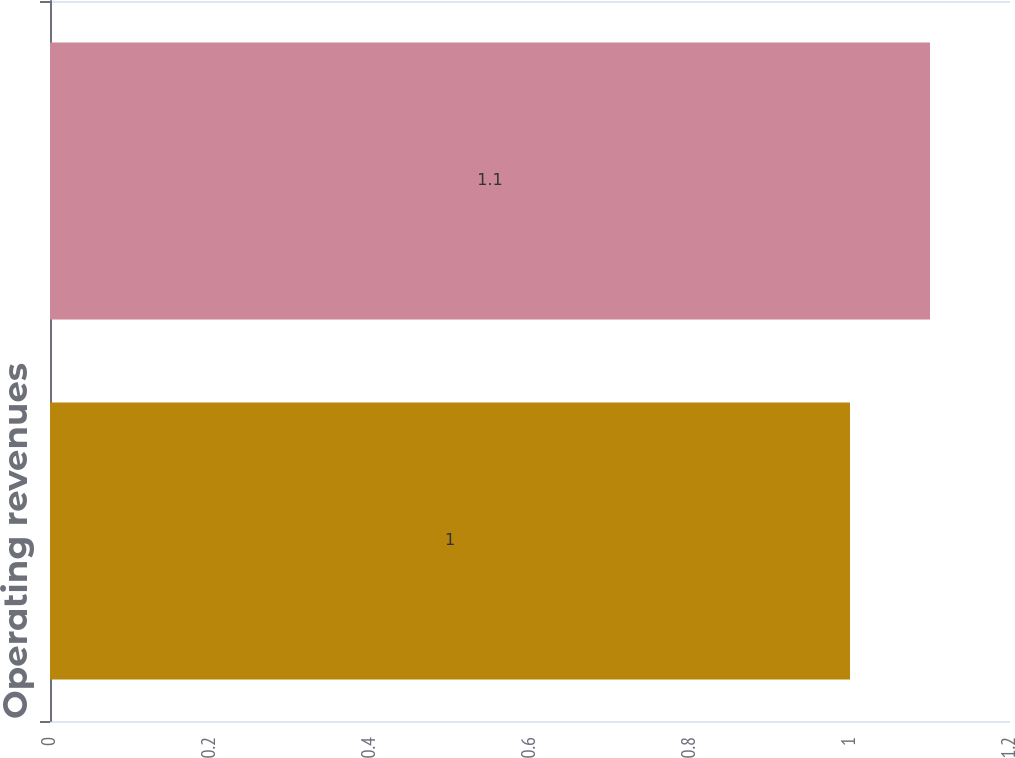Convert chart to OTSL. <chart><loc_0><loc_0><loc_500><loc_500><bar_chart><fcel>Operating revenues<fcel>Other operations and<nl><fcel>1<fcel>1.1<nl></chart> 